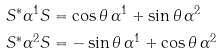Convert formula to latex. <formula><loc_0><loc_0><loc_500><loc_500>S ^ { * } \alpha ^ { 1 } S & = \cos \theta \, \alpha ^ { 1 } + \sin \theta \, \alpha ^ { 2 } \\ S ^ { * } \alpha ^ { 2 } S & = - \sin \theta \, \alpha ^ { 1 } + \cos \theta \, \alpha ^ { 2 }</formula> 